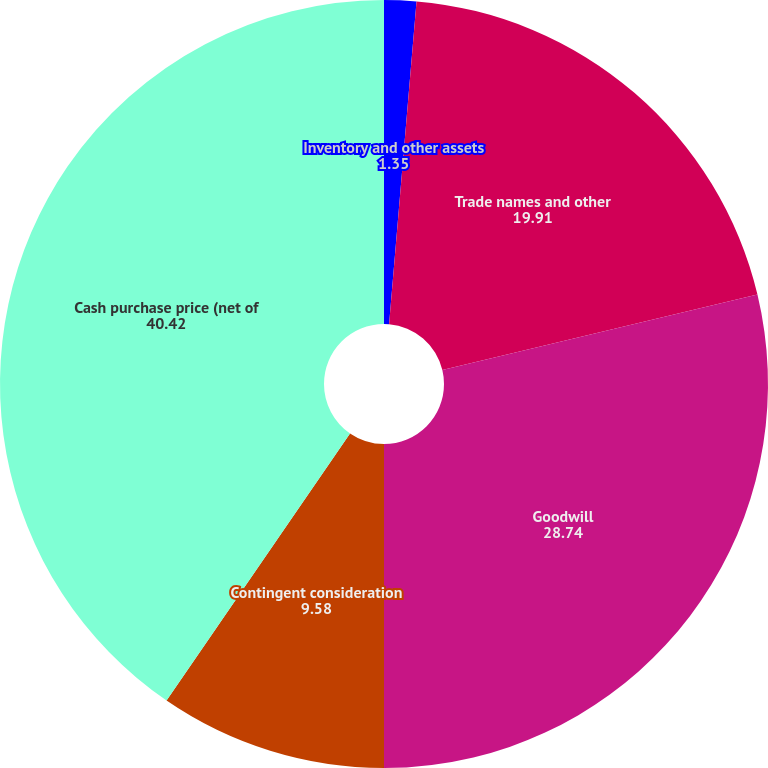Convert chart. <chart><loc_0><loc_0><loc_500><loc_500><pie_chart><fcel>Inventory and other assets<fcel>Trade names and other<fcel>Goodwill<fcel>Contingent consideration<fcel>Cash purchase price (net of<nl><fcel>1.35%<fcel>19.91%<fcel>28.74%<fcel>9.58%<fcel>40.42%<nl></chart> 